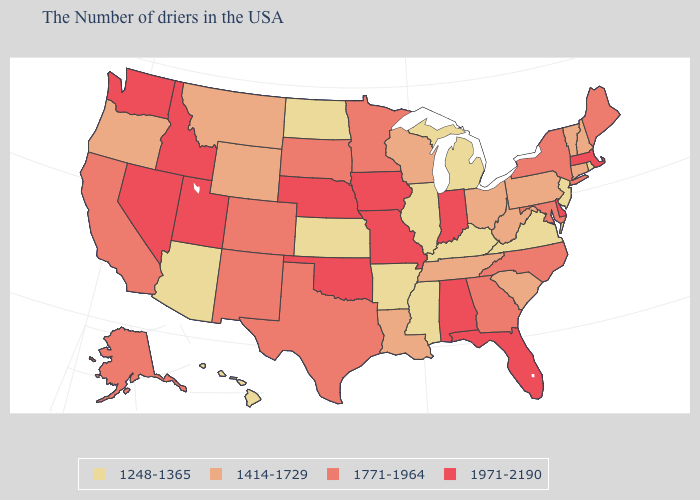Does New Mexico have the highest value in the West?
Concise answer only. No. Name the states that have a value in the range 1248-1365?
Give a very brief answer. Rhode Island, New Jersey, Virginia, Michigan, Kentucky, Illinois, Mississippi, Arkansas, Kansas, North Dakota, Arizona, Hawaii. Name the states that have a value in the range 1248-1365?
Be succinct. Rhode Island, New Jersey, Virginia, Michigan, Kentucky, Illinois, Mississippi, Arkansas, Kansas, North Dakota, Arizona, Hawaii. Which states have the highest value in the USA?
Give a very brief answer. Massachusetts, Delaware, Florida, Indiana, Alabama, Missouri, Iowa, Nebraska, Oklahoma, Utah, Idaho, Nevada, Washington. What is the highest value in the MidWest ?
Short answer required. 1971-2190. Name the states that have a value in the range 1414-1729?
Give a very brief answer. New Hampshire, Vermont, Connecticut, Pennsylvania, South Carolina, West Virginia, Ohio, Tennessee, Wisconsin, Louisiana, Wyoming, Montana, Oregon. What is the value of Alaska?
Short answer required. 1771-1964. Is the legend a continuous bar?
Answer briefly. No. Does Illinois have the lowest value in the MidWest?
Be succinct. Yes. Name the states that have a value in the range 1248-1365?
Concise answer only. Rhode Island, New Jersey, Virginia, Michigan, Kentucky, Illinois, Mississippi, Arkansas, Kansas, North Dakota, Arizona, Hawaii. Does Nebraska have the lowest value in the MidWest?
Answer briefly. No. Which states have the highest value in the USA?
Be succinct. Massachusetts, Delaware, Florida, Indiana, Alabama, Missouri, Iowa, Nebraska, Oklahoma, Utah, Idaho, Nevada, Washington. What is the value of Alabama?
Give a very brief answer. 1971-2190. Name the states that have a value in the range 1414-1729?
Write a very short answer. New Hampshire, Vermont, Connecticut, Pennsylvania, South Carolina, West Virginia, Ohio, Tennessee, Wisconsin, Louisiana, Wyoming, Montana, Oregon. What is the value of Rhode Island?
Short answer required. 1248-1365. 